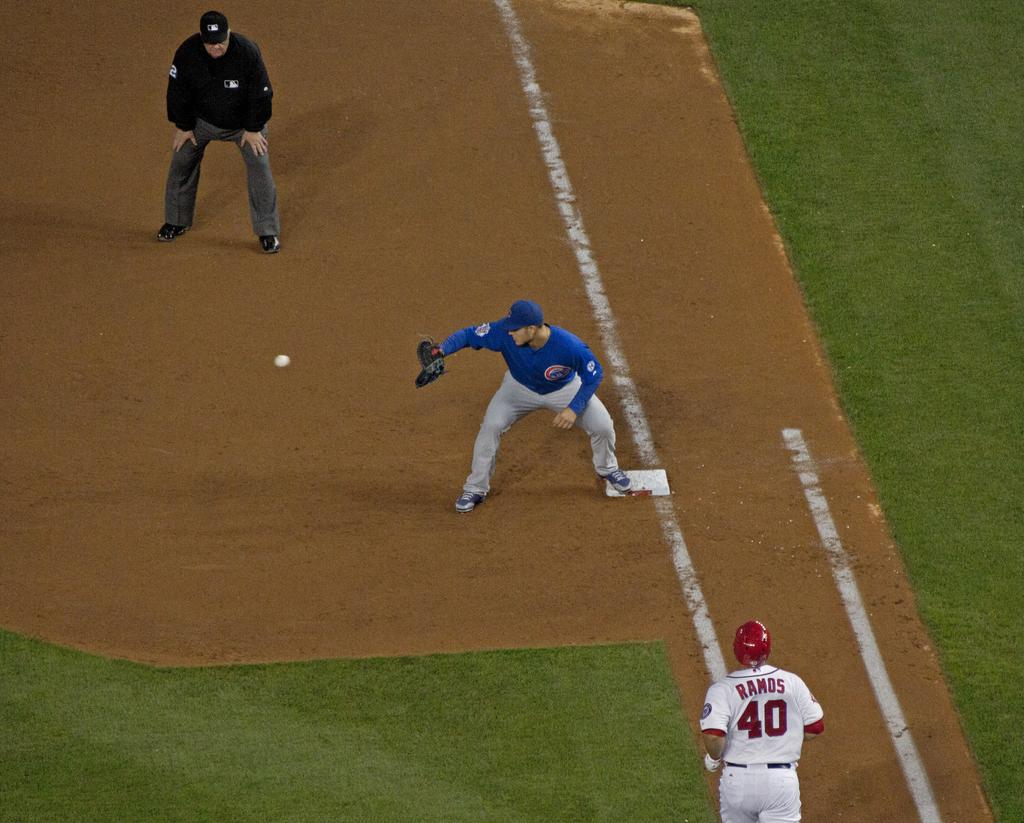Provide a one-sentence caption for the provided image. Professional baseball player Ramos number fourth running to first base. 